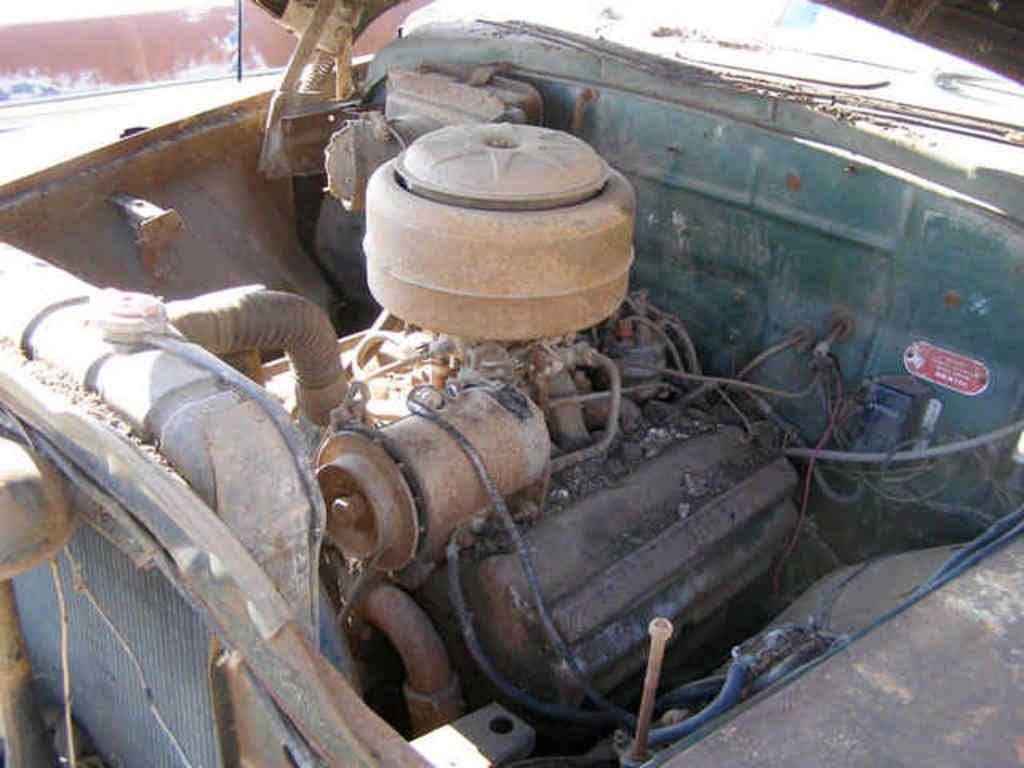Can you describe this image briefly? In this image I can see the motor in the vehicle. To the side I can see the road and the brown color wall. 